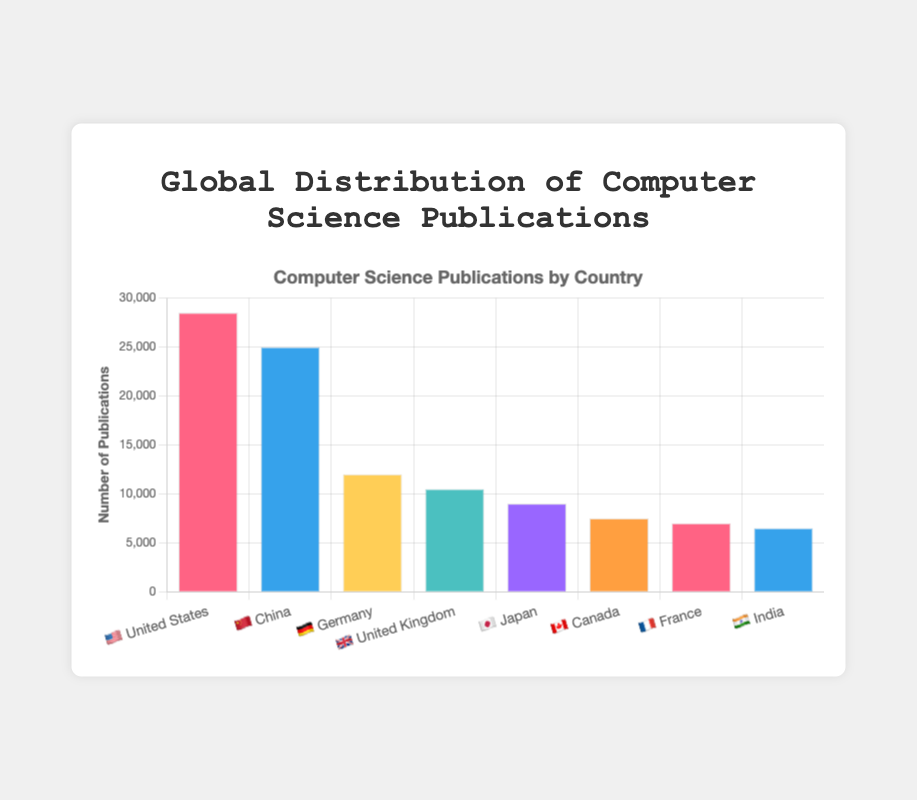What is the total number of computer science publications from 🇺🇸 United States? The figure shows that the United States has 28,500 computer science publications.
Answer: 28,500 Which country has the second highest number of computer science publications? By comparing the height of the bars, China 🇨🇳 has the second highest number of publications.
Answer: China How many more publications does the 🇺🇸 United States have compared to 🇩🇪 Germany? The United States has 28,500 publications, and Germany has 12,000. The difference is 28,500 - 12,000 = 16,500 publications.
Answer: 16,500 Which country has the lowest number of computer science publications, and how many are there? Among the countries listed, India 🇮🇳 has the lowest number of publications at 6,500.
Answer: India, 6,500 What is the total number of computer science publications for 🇫🇷 France and 🇮🇳 India combined? France has 7,000 publications, and India has 6,500. The total is 7,000 + 6,500 = 13,500 publications.
Answer: 13,500 How does the number of publications from 🇨🇦 Canada compare to 🇯🇵 Japan? Canada has 7,500 publications while Japan has 9,000. Japan has 1,500 more publications than Canada.
Answer: Japan has 1,500 more Which country has slightly over half the number of publications compared to 🇨🇳 China? China has 25,000 publications; Germany has 12,000 which is slightly over half of China’s publications.
Answer: Germany What is the average number of publications among all listed countries? Sum all publications (28,500 + 25,000 + 12,000 + 10,500 + 9,000 + 7,500 + 7,000 + 6,500 = 106,000) and divide by the number of countries (8): 106,000 / 8 = 13,250 publications.
Answer: 13,250 Which countries have less than 10,000 publications? By observing the chart, the countries with less than 10,000 publications are: Japan 🇯🇵, Canada 🇨🇦, France 🇫🇷, and India 🇮🇳.
Answer: Japan, Canada, France, India 